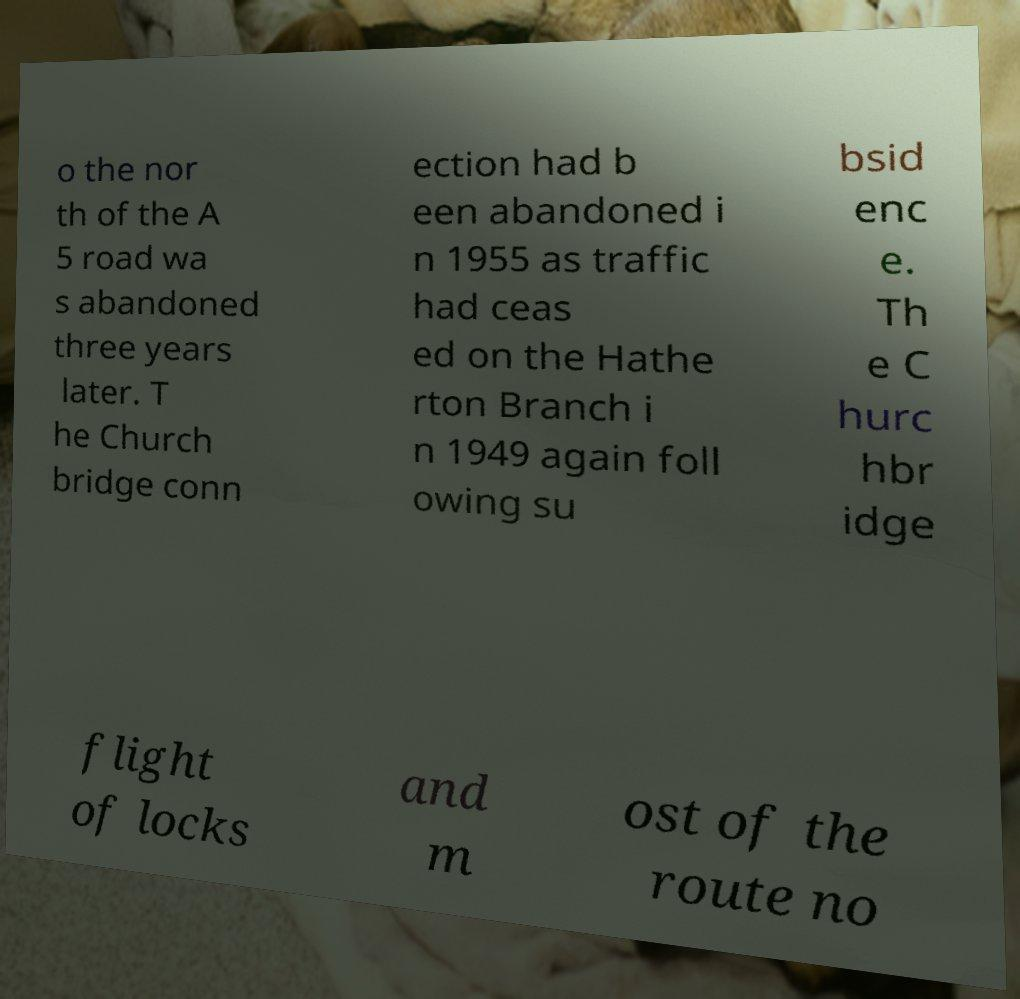I need the written content from this picture converted into text. Can you do that? o the nor th of the A 5 road wa s abandoned three years later. T he Church bridge conn ection had b een abandoned i n 1955 as traffic had ceas ed on the Hathe rton Branch i n 1949 again foll owing su bsid enc e. Th e C hurc hbr idge flight of locks and m ost of the route no 